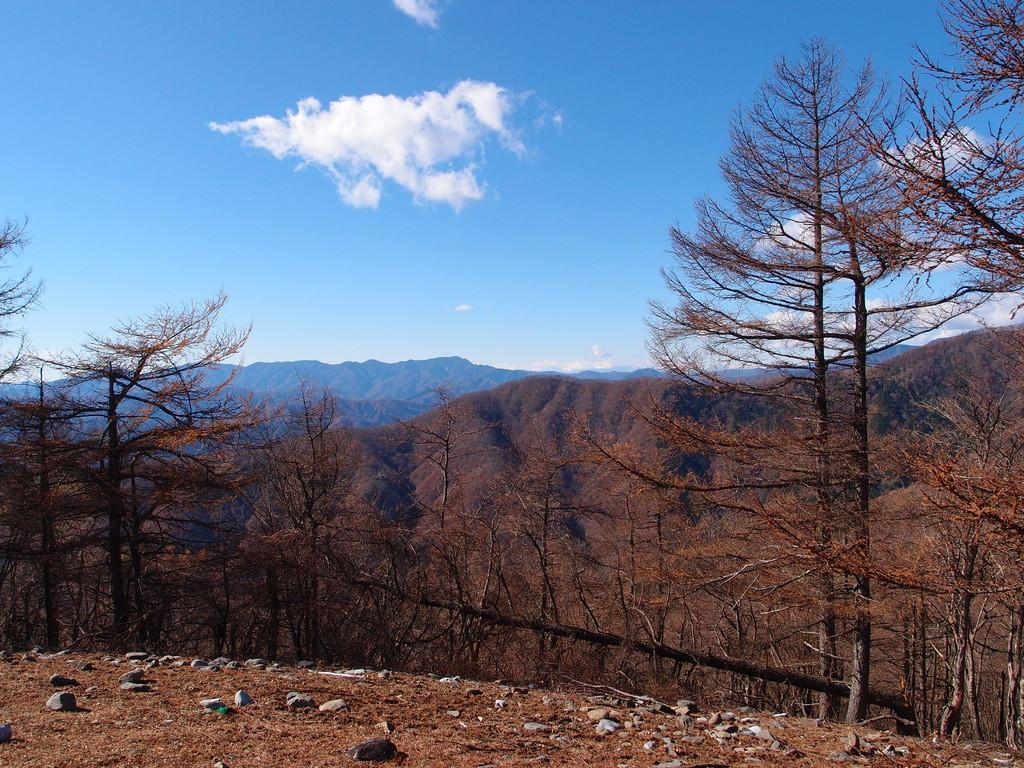What type of natural features can be seen in the image? There are trees and mountains in the image. What is on the ground in the image? There are stones on the ground in the image. What is the condition of the sky in the image? The sky is cloudy in the image. How many weeks can be seen in the image? There are no weeks visible in the image, as weeks are a unit of time and not a physical object that can be seen. 